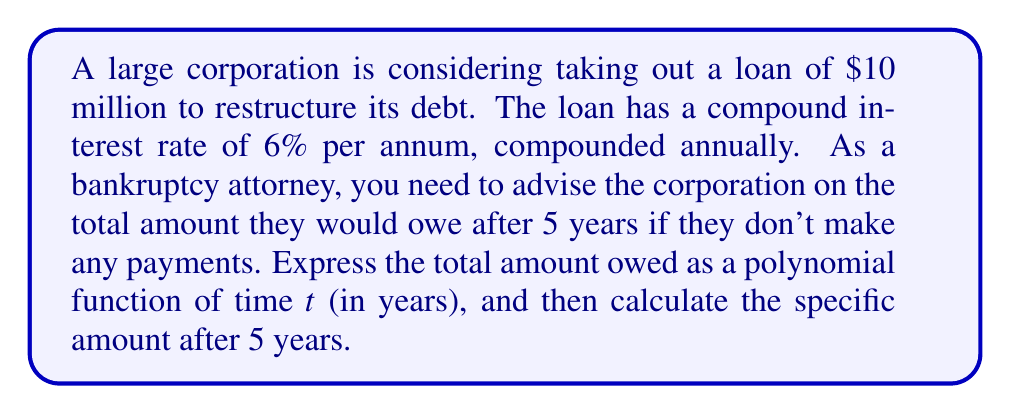Can you solve this math problem? Let's approach this step-by-step:

1) The formula for compound interest is:
   
   $A = P(1 + r)^t$

   Where:
   $A$ = Final amount
   $P$ = Principal (initial investment)
   $r$ = Annual interest rate (in decimal form)
   $t$ = Number of years

2) In this case:
   $P = 10,000,000$
   $r = 0.06$
   
3) Let's express this as a polynomial function of $t$:

   $A(t) = 10,000,000(1 + 0.06)^t$

4) Expanding $(1 + 0.06)^t$ using the binomial theorem:

   $(1 + 0.06)^t = 1 + 0.06t + \frac{0.06^2t(t-1)}{2!} + \frac{0.06^3t(t-1)(t-2)}{3!} + ...$

5) Multiplying by 10,000,000 and simplifying:

   $A(t) = 10,000,000 + 600,000t + 18,000t^2 + 360t^3 + 5.4t^4 + 0.0648t^5 + ...$

6) To find the amount after 5 years, we substitute $t = 5$:

   $A(5) = 10,000,000 + 600,000(5) + 18,000(5^2) + 360(5^3) + 5.4(5^4) + 0.0648(5^5) + ...$
   
   $= 10,000,000 + 3,000,000 + 450,000 + 45,000 + 3,375 + 405 + ...$
   
   $= 13,382,256$ (rounded to the nearest dollar)
Answer: The total amount owed after 5 years would be $13,382,256. 